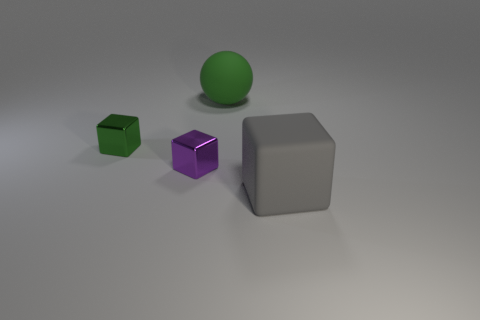There is a object that is the same color as the large matte ball; what is it made of?
Offer a terse response. Metal. How many objects are large rubber things behind the large gray matte object or purple metallic objects?
Your answer should be very brief. 2. There is a rubber thing that is left of the gray object; does it have the same size as the tiny green metal cube?
Your response must be concise. No. Are there fewer large rubber balls in front of the tiny green metal thing than large rubber balls?
Offer a terse response. Yes. What material is the green cube that is the same size as the purple cube?
Keep it short and to the point. Metal. What number of large objects are gray rubber blocks or yellow metal cubes?
Your answer should be compact. 1. How many objects are big green matte things that are behind the small purple block or big things that are in front of the green rubber ball?
Provide a succinct answer. 2. Is the number of tiny purple blocks less than the number of large purple cubes?
Your answer should be very brief. No. What is the shape of the other thing that is the same size as the green rubber object?
Provide a succinct answer. Cube. How many other things are there of the same color as the rubber sphere?
Ensure brevity in your answer.  1. 